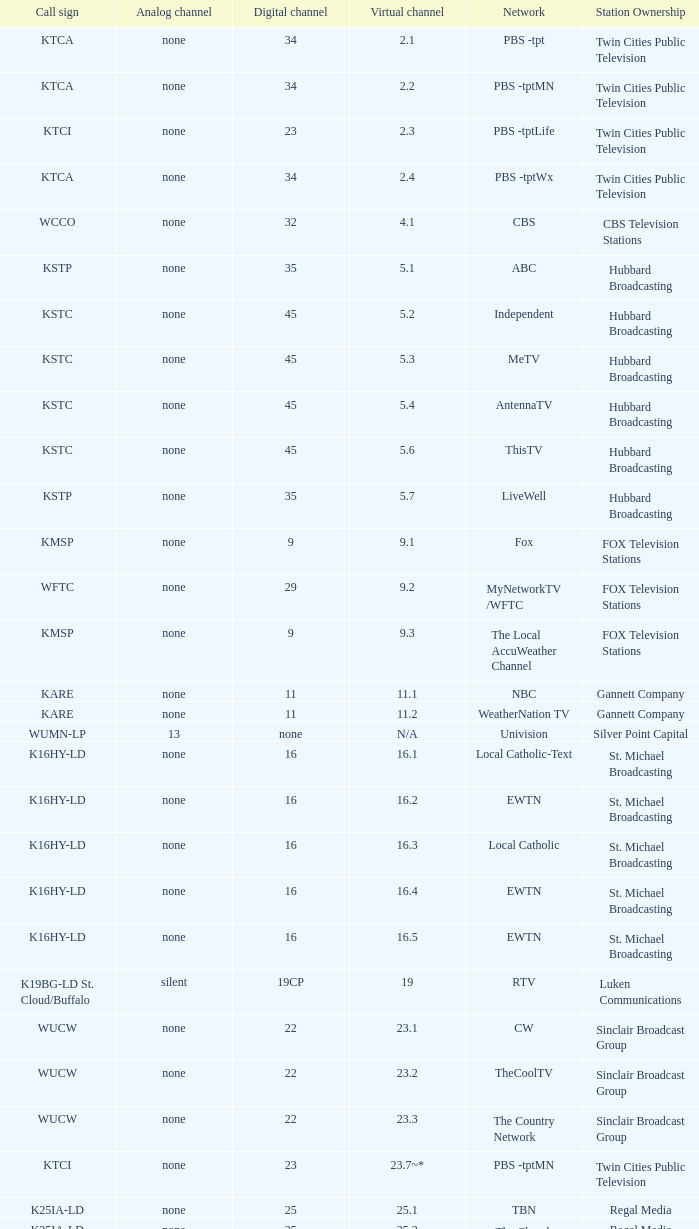What call sign is associated with virtual channel 16.5? K16HY-LD. 